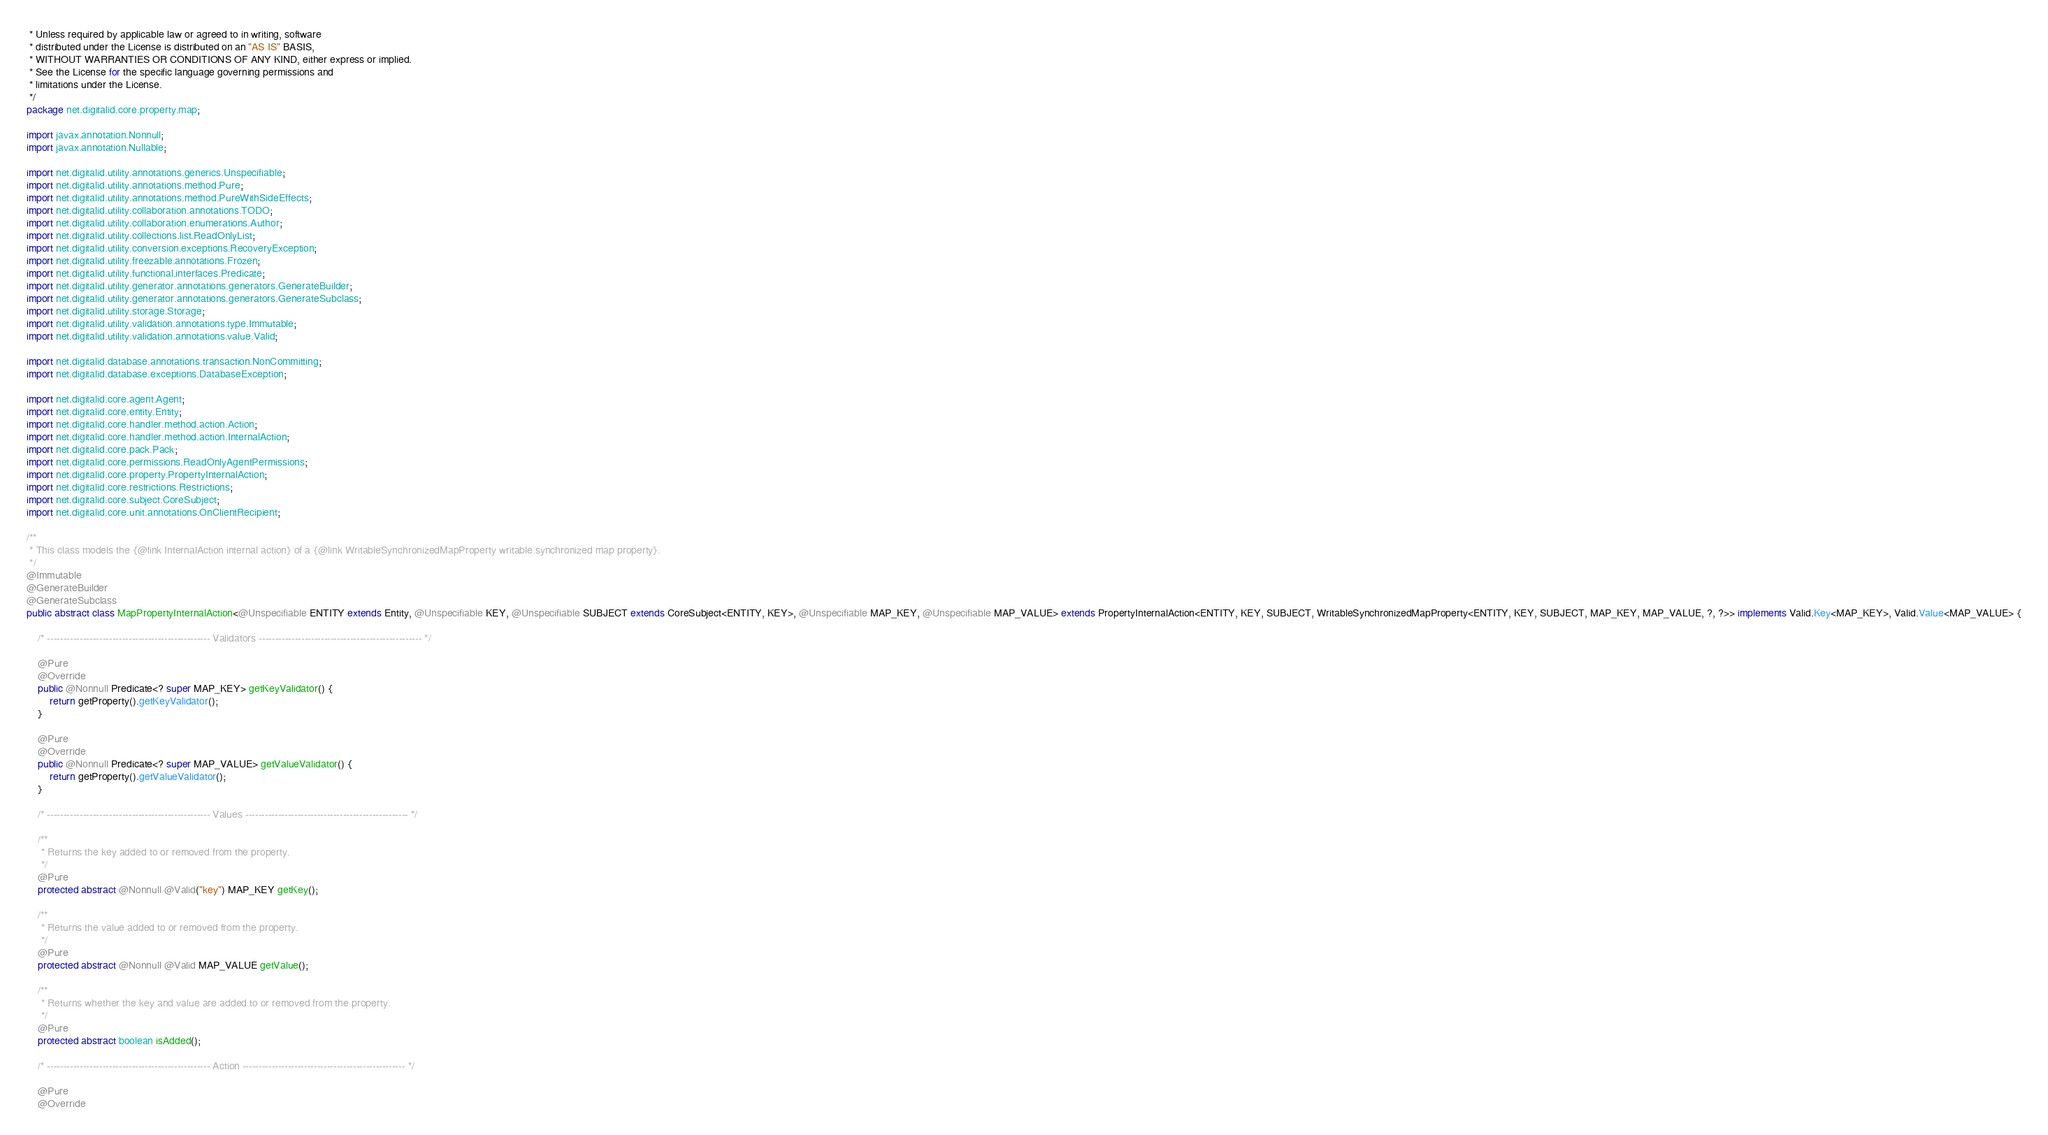Convert code to text. <code><loc_0><loc_0><loc_500><loc_500><_Java_> * Unless required by applicable law or agreed to in writing, software
 * distributed under the License is distributed on an "AS IS" BASIS,
 * WITHOUT WARRANTIES OR CONDITIONS OF ANY KIND, either express or implied.
 * See the License for the specific language governing permissions and
 * limitations under the License.
 */
package net.digitalid.core.property.map;

import javax.annotation.Nonnull;
import javax.annotation.Nullable;

import net.digitalid.utility.annotations.generics.Unspecifiable;
import net.digitalid.utility.annotations.method.Pure;
import net.digitalid.utility.annotations.method.PureWithSideEffects;
import net.digitalid.utility.collaboration.annotations.TODO;
import net.digitalid.utility.collaboration.enumerations.Author;
import net.digitalid.utility.collections.list.ReadOnlyList;
import net.digitalid.utility.conversion.exceptions.RecoveryException;
import net.digitalid.utility.freezable.annotations.Frozen;
import net.digitalid.utility.functional.interfaces.Predicate;
import net.digitalid.utility.generator.annotations.generators.GenerateBuilder;
import net.digitalid.utility.generator.annotations.generators.GenerateSubclass;
import net.digitalid.utility.storage.Storage;
import net.digitalid.utility.validation.annotations.type.Immutable;
import net.digitalid.utility.validation.annotations.value.Valid;

import net.digitalid.database.annotations.transaction.NonCommitting;
import net.digitalid.database.exceptions.DatabaseException;

import net.digitalid.core.agent.Agent;
import net.digitalid.core.entity.Entity;
import net.digitalid.core.handler.method.action.Action;
import net.digitalid.core.handler.method.action.InternalAction;
import net.digitalid.core.pack.Pack;
import net.digitalid.core.permissions.ReadOnlyAgentPermissions;
import net.digitalid.core.property.PropertyInternalAction;
import net.digitalid.core.restrictions.Restrictions;
import net.digitalid.core.subject.CoreSubject;
import net.digitalid.core.unit.annotations.OnClientRecipient;

/**
 * This class models the {@link InternalAction internal action} of a {@link WritableSynchronizedMapProperty writable synchronized map property}.
 */
@Immutable
@GenerateBuilder
@GenerateSubclass
public abstract class MapPropertyInternalAction<@Unspecifiable ENTITY extends Entity, @Unspecifiable KEY, @Unspecifiable SUBJECT extends CoreSubject<ENTITY, KEY>, @Unspecifiable MAP_KEY, @Unspecifiable MAP_VALUE> extends PropertyInternalAction<ENTITY, KEY, SUBJECT, WritableSynchronizedMapProperty<ENTITY, KEY, SUBJECT, MAP_KEY, MAP_VALUE, ?, ?>> implements Valid.Key<MAP_KEY>, Valid.Value<MAP_VALUE> {
    
    /* -------------------------------------------------- Validators -------------------------------------------------- */
    
    @Pure
    @Override
    public @Nonnull Predicate<? super MAP_KEY> getKeyValidator() {
        return getProperty().getKeyValidator();
    }
    
    @Pure
    @Override
    public @Nonnull Predicate<? super MAP_VALUE> getValueValidator() {
        return getProperty().getValueValidator();
    }
    
    /* -------------------------------------------------- Values -------------------------------------------------- */
    
    /**
     * Returns the key added to or removed from the property.
     */
    @Pure
    protected abstract @Nonnull @Valid("key") MAP_KEY getKey();
    
    /**
     * Returns the value added to or removed from the property.
     */
    @Pure
    protected abstract @Nonnull @Valid MAP_VALUE getValue();
    
    /**
     * Returns whether the key and value are added to or removed from the property.
     */
    @Pure
    protected abstract boolean isAdded();
    
    /* -------------------------------------------------- Action -------------------------------------------------- */
    
    @Pure
    @Override</code> 